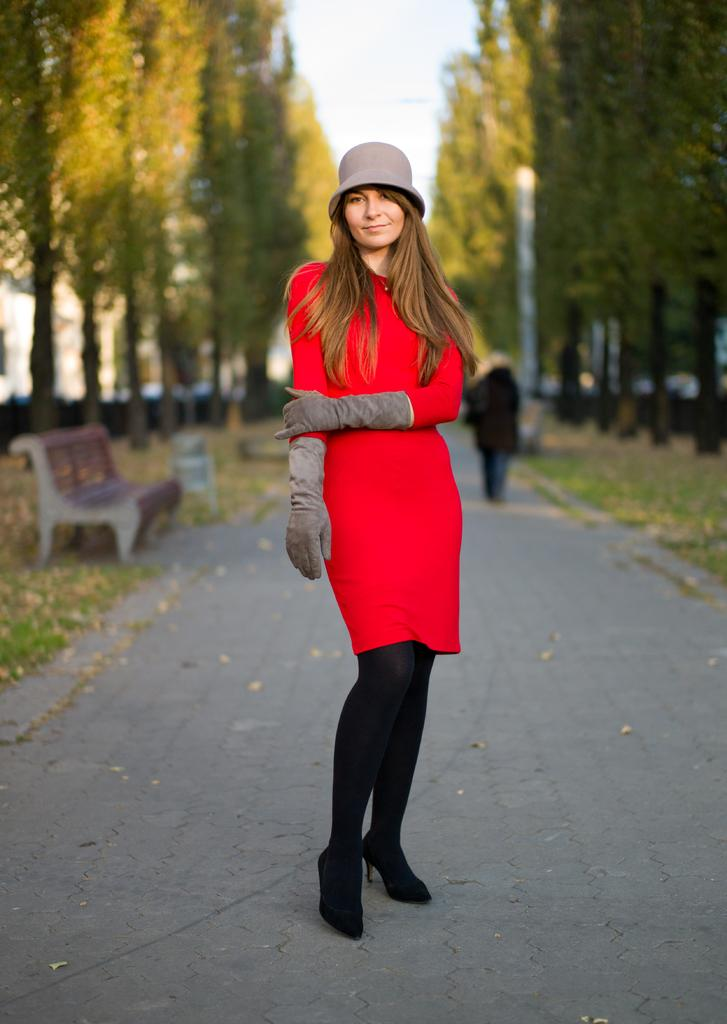Who is present in the image? There is a woman in the image. What can be seen in the background of the image? There are trees in the background of the image. What object is in the image that could be used for sitting? There is a bench in the image. What is the condition of the sky in the image? The sky is clear in the image. What type of book is the woman reading in the image? There is no book present in the image; the woman is not reading. 